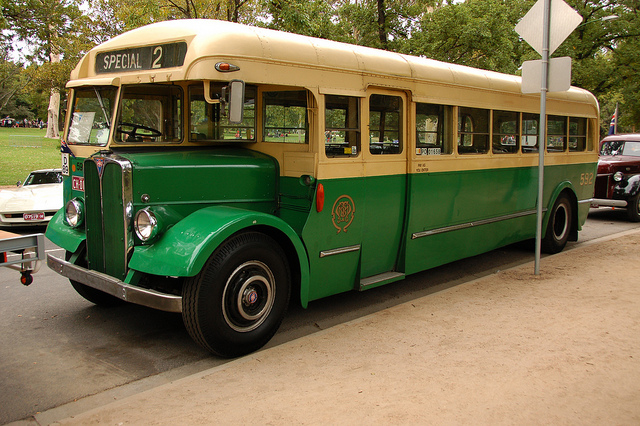<image>What color is the train? There is no train in the image. However, it can be green and yellow or green and tan. What color is the train? There is no train in the image. 